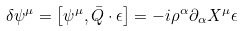<formula> <loc_0><loc_0><loc_500><loc_500>\delta \psi ^ { \mu } = \left [ \psi ^ { \mu } , \bar { Q } \cdot \epsilon \right ] = - i \rho ^ { \alpha } \partial _ { \alpha } X ^ { \mu } \epsilon</formula> 